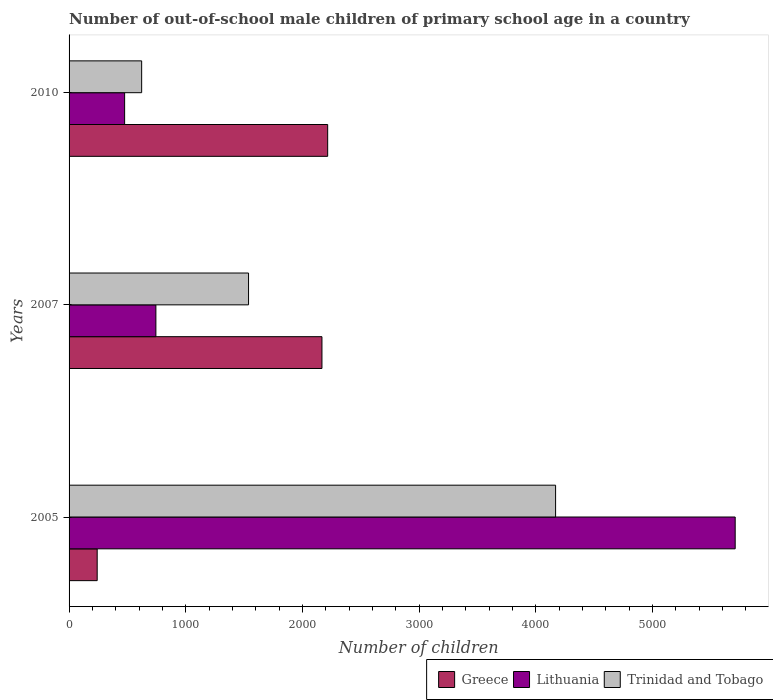How many different coloured bars are there?
Provide a short and direct response. 3. Are the number of bars per tick equal to the number of legend labels?
Your answer should be compact. Yes. In how many cases, is the number of bars for a given year not equal to the number of legend labels?
Provide a succinct answer. 0. What is the number of out-of-school male children in Trinidad and Tobago in 2007?
Offer a terse response. 1538. Across all years, what is the maximum number of out-of-school male children in Lithuania?
Provide a short and direct response. 5708. Across all years, what is the minimum number of out-of-school male children in Greece?
Your answer should be very brief. 241. In which year was the number of out-of-school male children in Greece maximum?
Your answer should be compact. 2010. In which year was the number of out-of-school male children in Trinidad and Tobago minimum?
Keep it short and to the point. 2010. What is the total number of out-of-school male children in Lithuania in the graph?
Offer a terse response. 6928. What is the difference between the number of out-of-school male children in Trinidad and Tobago in 2007 and that in 2010?
Offer a terse response. 916. What is the difference between the number of out-of-school male children in Trinidad and Tobago in 2005 and the number of out-of-school male children in Lithuania in 2007?
Give a very brief answer. 3425. What is the average number of out-of-school male children in Trinidad and Tobago per year?
Provide a succinct answer. 2109.67. In the year 2005, what is the difference between the number of out-of-school male children in Lithuania and number of out-of-school male children in Greece?
Your answer should be compact. 5467. What is the ratio of the number of out-of-school male children in Lithuania in 2005 to that in 2007?
Your answer should be compact. 7.67. Is the number of out-of-school male children in Lithuania in 2007 less than that in 2010?
Your response must be concise. No. What is the difference between the highest and the second highest number of out-of-school male children in Trinidad and Tobago?
Ensure brevity in your answer.  2631. What is the difference between the highest and the lowest number of out-of-school male children in Trinidad and Tobago?
Keep it short and to the point. 3547. In how many years, is the number of out-of-school male children in Lithuania greater than the average number of out-of-school male children in Lithuania taken over all years?
Ensure brevity in your answer.  1. Is the sum of the number of out-of-school male children in Greece in 2005 and 2010 greater than the maximum number of out-of-school male children in Trinidad and Tobago across all years?
Provide a succinct answer. No. What does the 1st bar from the top in 2005 represents?
Provide a succinct answer. Trinidad and Tobago. What does the 2nd bar from the bottom in 2005 represents?
Keep it short and to the point. Lithuania. How many bars are there?
Your answer should be compact. 9. Are all the bars in the graph horizontal?
Your response must be concise. Yes. How many years are there in the graph?
Your answer should be compact. 3. Are the values on the major ticks of X-axis written in scientific E-notation?
Keep it short and to the point. No. Where does the legend appear in the graph?
Your response must be concise. Bottom right. How many legend labels are there?
Give a very brief answer. 3. What is the title of the graph?
Provide a succinct answer. Number of out-of-school male children of primary school age in a country. Does "Ireland" appear as one of the legend labels in the graph?
Your response must be concise. No. What is the label or title of the X-axis?
Provide a short and direct response. Number of children. What is the label or title of the Y-axis?
Offer a very short reply. Years. What is the Number of children in Greece in 2005?
Ensure brevity in your answer.  241. What is the Number of children of Lithuania in 2005?
Your response must be concise. 5708. What is the Number of children of Trinidad and Tobago in 2005?
Your answer should be very brief. 4169. What is the Number of children of Greece in 2007?
Provide a short and direct response. 2167. What is the Number of children in Lithuania in 2007?
Provide a short and direct response. 744. What is the Number of children in Trinidad and Tobago in 2007?
Provide a short and direct response. 1538. What is the Number of children of Greece in 2010?
Provide a succinct answer. 2216. What is the Number of children in Lithuania in 2010?
Offer a terse response. 476. What is the Number of children in Trinidad and Tobago in 2010?
Your answer should be compact. 622. Across all years, what is the maximum Number of children of Greece?
Your response must be concise. 2216. Across all years, what is the maximum Number of children in Lithuania?
Ensure brevity in your answer.  5708. Across all years, what is the maximum Number of children in Trinidad and Tobago?
Offer a terse response. 4169. Across all years, what is the minimum Number of children in Greece?
Your response must be concise. 241. Across all years, what is the minimum Number of children in Lithuania?
Give a very brief answer. 476. Across all years, what is the minimum Number of children in Trinidad and Tobago?
Offer a very short reply. 622. What is the total Number of children in Greece in the graph?
Provide a succinct answer. 4624. What is the total Number of children in Lithuania in the graph?
Offer a very short reply. 6928. What is the total Number of children in Trinidad and Tobago in the graph?
Give a very brief answer. 6329. What is the difference between the Number of children of Greece in 2005 and that in 2007?
Provide a short and direct response. -1926. What is the difference between the Number of children in Lithuania in 2005 and that in 2007?
Offer a very short reply. 4964. What is the difference between the Number of children in Trinidad and Tobago in 2005 and that in 2007?
Offer a terse response. 2631. What is the difference between the Number of children of Greece in 2005 and that in 2010?
Provide a short and direct response. -1975. What is the difference between the Number of children in Lithuania in 2005 and that in 2010?
Keep it short and to the point. 5232. What is the difference between the Number of children of Trinidad and Tobago in 2005 and that in 2010?
Ensure brevity in your answer.  3547. What is the difference between the Number of children in Greece in 2007 and that in 2010?
Give a very brief answer. -49. What is the difference between the Number of children of Lithuania in 2007 and that in 2010?
Keep it short and to the point. 268. What is the difference between the Number of children in Trinidad and Tobago in 2007 and that in 2010?
Make the answer very short. 916. What is the difference between the Number of children in Greece in 2005 and the Number of children in Lithuania in 2007?
Your answer should be very brief. -503. What is the difference between the Number of children of Greece in 2005 and the Number of children of Trinidad and Tobago in 2007?
Your answer should be very brief. -1297. What is the difference between the Number of children in Lithuania in 2005 and the Number of children in Trinidad and Tobago in 2007?
Provide a short and direct response. 4170. What is the difference between the Number of children in Greece in 2005 and the Number of children in Lithuania in 2010?
Give a very brief answer. -235. What is the difference between the Number of children in Greece in 2005 and the Number of children in Trinidad and Tobago in 2010?
Your response must be concise. -381. What is the difference between the Number of children in Lithuania in 2005 and the Number of children in Trinidad and Tobago in 2010?
Provide a succinct answer. 5086. What is the difference between the Number of children of Greece in 2007 and the Number of children of Lithuania in 2010?
Provide a succinct answer. 1691. What is the difference between the Number of children in Greece in 2007 and the Number of children in Trinidad and Tobago in 2010?
Keep it short and to the point. 1545. What is the difference between the Number of children of Lithuania in 2007 and the Number of children of Trinidad and Tobago in 2010?
Offer a terse response. 122. What is the average Number of children in Greece per year?
Offer a terse response. 1541.33. What is the average Number of children in Lithuania per year?
Keep it short and to the point. 2309.33. What is the average Number of children of Trinidad and Tobago per year?
Provide a short and direct response. 2109.67. In the year 2005, what is the difference between the Number of children of Greece and Number of children of Lithuania?
Your response must be concise. -5467. In the year 2005, what is the difference between the Number of children of Greece and Number of children of Trinidad and Tobago?
Give a very brief answer. -3928. In the year 2005, what is the difference between the Number of children of Lithuania and Number of children of Trinidad and Tobago?
Make the answer very short. 1539. In the year 2007, what is the difference between the Number of children of Greece and Number of children of Lithuania?
Offer a very short reply. 1423. In the year 2007, what is the difference between the Number of children in Greece and Number of children in Trinidad and Tobago?
Provide a succinct answer. 629. In the year 2007, what is the difference between the Number of children in Lithuania and Number of children in Trinidad and Tobago?
Ensure brevity in your answer.  -794. In the year 2010, what is the difference between the Number of children of Greece and Number of children of Lithuania?
Offer a terse response. 1740. In the year 2010, what is the difference between the Number of children in Greece and Number of children in Trinidad and Tobago?
Make the answer very short. 1594. In the year 2010, what is the difference between the Number of children in Lithuania and Number of children in Trinidad and Tobago?
Offer a terse response. -146. What is the ratio of the Number of children in Greece in 2005 to that in 2007?
Offer a terse response. 0.11. What is the ratio of the Number of children in Lithuania in 2005 to that in 2007?
Make the answer very short. 7.67. What is the ratio of the Number of children in Trinidad and Tobago in 2005 to that in 2007?
Provide a short and direct response. 2.71. What is the ratio of the Number of children of Greece in 2005 to that in 2010?
Your answer should be compact. 0.11. What is the ratio of the Number of children in Lithuania in 2005 to that in 2010?
Ensure brevity in your answer.  11.99. What is the ratio of the Number of children of Trinidad and Tobago in 2005 to that in 2010?
Your answer should be compact. 6.7. What is the ratio of the Number of children in Greece in 2007 to that in 2010?
Your response must be concise. 0.98. What is the ratio of the Number of children in Lithuania in 2007 to that in 2010?
Your answer should be very brief. 1.56. What is the ratio of the Number of children in Trinidad and Tobago in 2007 to that in 2010?
Give a very brief answer. 2.47. What is the difference between the highest and the second highest Number of children in Lithuania?
Ensure brevity in your answer.  4964. What is the difference between the highest and the second highest Number of children in Trinidad and Tobago?
Your response must be concise. 2631. What is the difference between the highest and the lowest Number of children of Greece?
Provide a succinct answer. 1975. What is the difference between the highest and the lowest Number of children of Lithuania?
Your answer should be compact. 5232. What is the difference between the highest and the lowest Number of children in Trinidad and Tobago?
Give a very brief answer. 3547. 